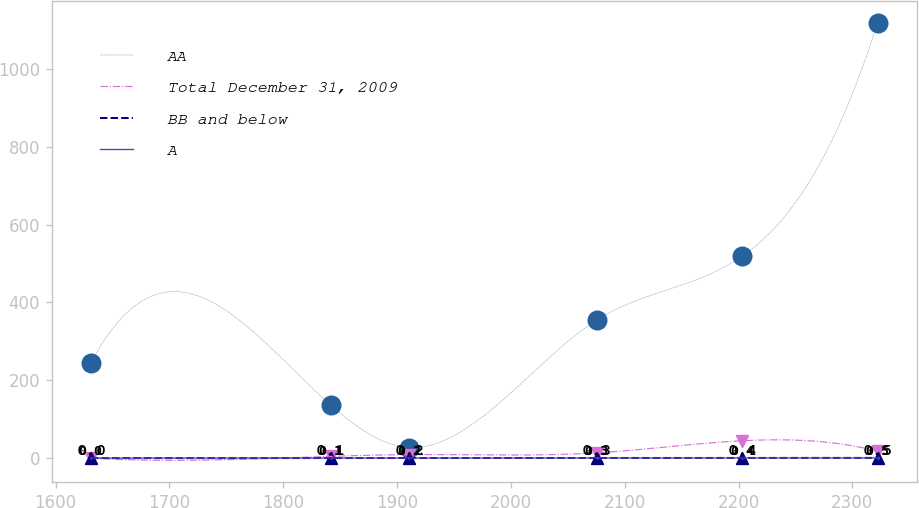Convert chart to OTSL. <chart><loc_0><loc_0><loc_500><loc_500><line_chart><ecel><fcel>AA<fcel>Total December 31, 2009<fcel>BB and below<fcel>A<nl><fcel>1631.1<fcel>245.38<fcel>0<fcel>0<fcel>0<nl><fcel>1841.74<fcel>136.24<fcel>4.45<fcel>0.1<fcel>0.1<nl><fcel>1910.85<fcel>27.1<fcel>8.9<fcel>0.2<fcel>0.2<nl><fcel>2075.4<fcel>354.52<fcel>13.35<fcel>0.3<fcel>0.3<nl><fcel>2203.28<fcel>518.93<fcel>44.51<fcel>0.4<fcel>0.4<nl><fcel>2322.15<fcel>1118.49<fcel>17.8<fcel>0.5<fcel>0.5<nl></chart> 